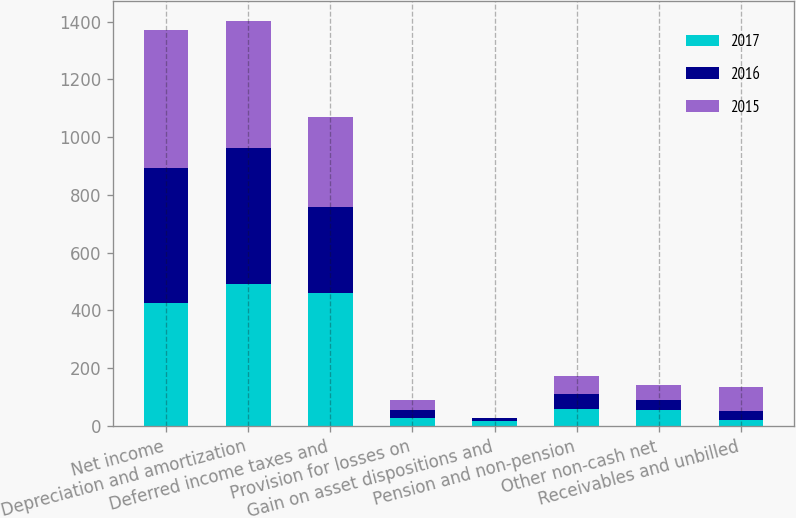Convert chart to OTSL. <chart><loc_0><loc_0><loc_500><loc_500><stacked_bar_chart><ecel><fcel>Net income<fcel>Depreciation and amortization<fcel>Deferred income taxes and<fcel>Provision for losses on<fcel>Gain on asset dispositions and<fcel>Pension and non-pension<fcel>Other non-cash net<fcel>Receivables and unbilled<nl><fcel>2017<fcel>426<fcel>492<fcel>462<fcel>29<fcel>16<fcel>57<fcel>54<fcel>21<nl><fcel>2016<fcel>468<fcel>470<fcel>295<fcel>27<fcel>10<fcel>54<fcel>36<fcel>31<nl><fcel>2015<fcel>476<fcel>440<fcel>312<fcel>32<fcel>3<fcel>61<fcel>53<fcel>84<nl></chart> 